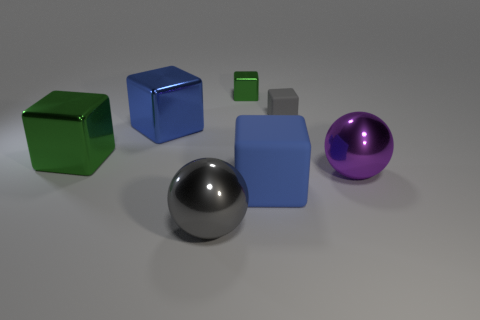Are there any other things that are the same size as the purple metallic ball?
Provide a succinct answer. Yes. Is there any other thing that is made of the same material as the purple object?
Provide a short and direct response. Yes. Does the small green object have the same material as the gray object that is behind the large blue metallic object?
Keep it short and to the point. No. There is a blue block that is right of the big blue cube left of the small green thing; what size is it?
Keep it short and to the point. Large. Is there anything else of the same color as the small metallic object?
Keep it short and to the point. Yes. Does the block to the left of the large blue shiny cube have the same material as the ball in front of the large purple object?
Give a very brief answer. Yes. What is the material of the object that is behind the large blue shiny block and in front of the small metallic block?
Your answer should be very brief. Rubber. Do the small gray thing and the large blue object that is to the left of the tiny metal block have the same shape?
Keep it short and to the point. Yes. There is a gray object that is in front of the green block on the left side of the large object in front of the big blue matte cube; what is its material?
Keep it short and to the point. Metal. How many other things are the same size as the gray sphere?
Your response must be concise. 4. 